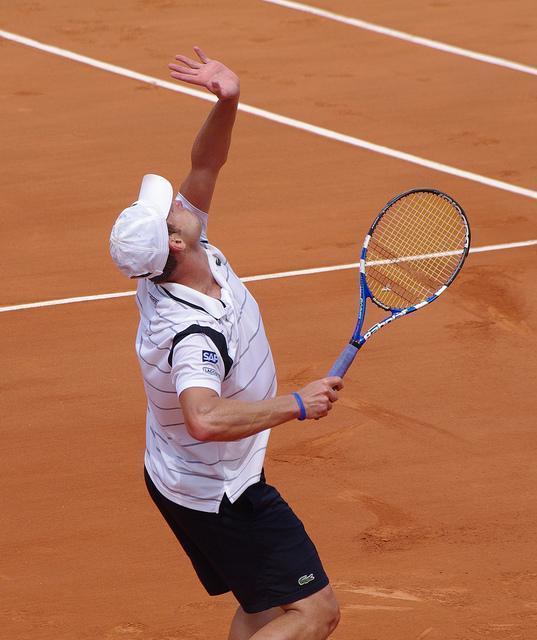How many bird legs can you see in this picture?
Give a very brief answer. 0. 